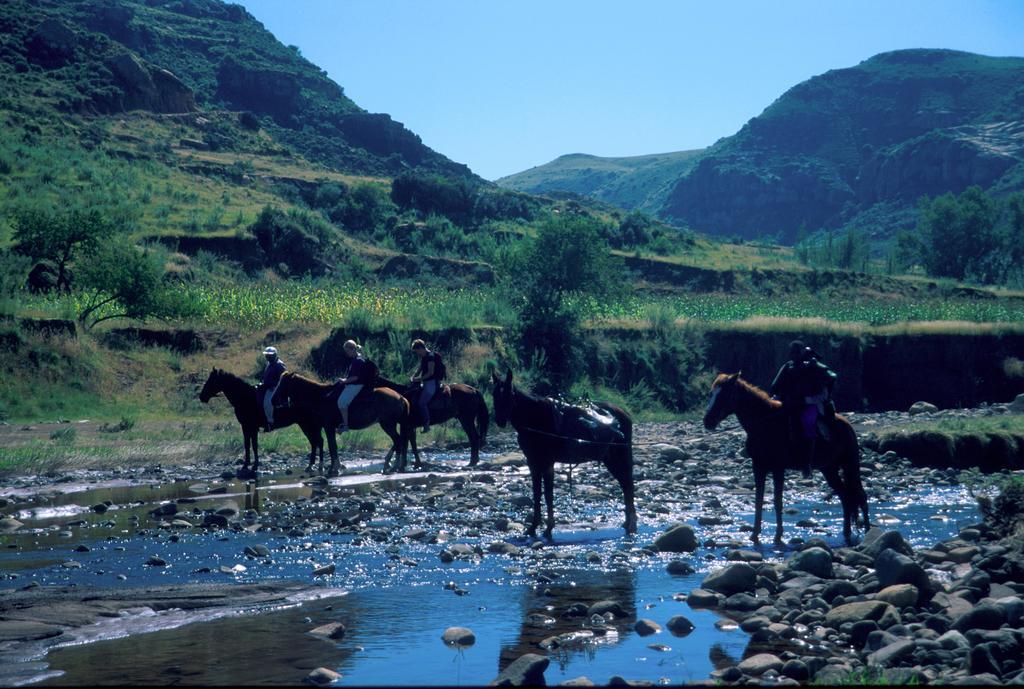Please provide a concise description of this image. This picture is clicked outside. In the foreground we can see the rocks and a water body. In the center we can see the group of people sitting on the horses and we can see a horse standing and we can see the green grass, plants, flowers. In the background we can see the sky, hills and the trees. 